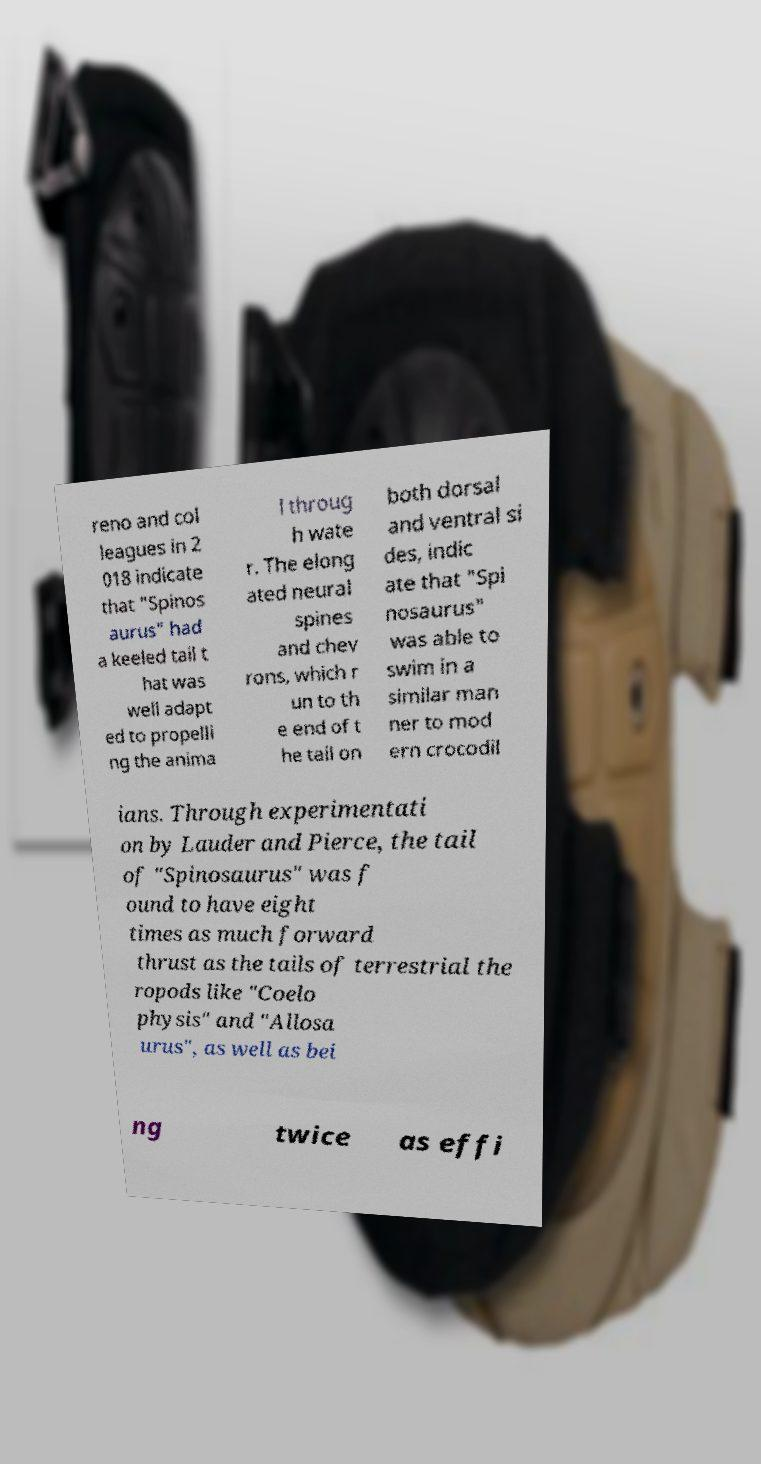Please identify and transcribe the text found in this image. reno and col leagues in 2 018 indicate that "Spinos aurus" had a keeled tail t hat was well adapt ed to propelli ng the anima l throug h wate r. The elong ated neural spines and chev rons, which r un to th e end of t he tail on both dorsal and ventral si des, indic ate that "Spi nosaurus" was able to swim in a similar man ner to mod ern crocodil ians. Through experimentati on by Lauder and Pierce, the tail of "Spinosaurus" was f ound to have eight times as much forward thrust as the tails of terrestrial the ropods like "Coelo physis" and "Allosa urus", as well as bei ng twice as effi 